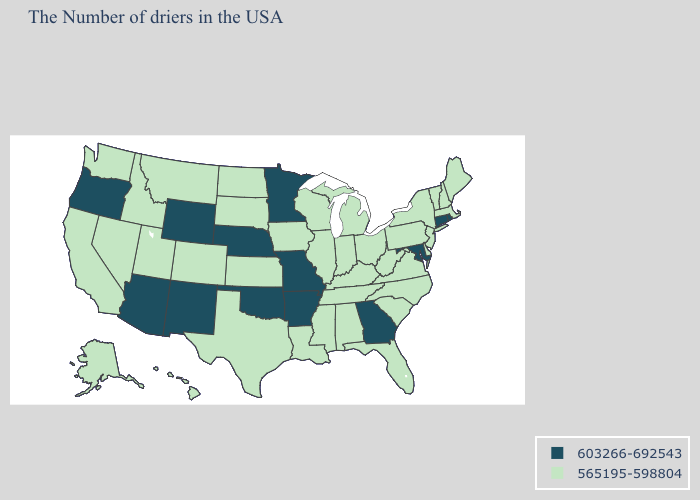What is the value of Indiana?
Answer briefly. 565195-598804. Name the states that have a value in the range 565195-598804?
Give a very brief answer. Maine, Massachusetts, New Hampshire, Vermont, New York, New Jersey, Delaware, Pennsylvania, Virginia, North Carolina, South Carolina, West Virginia, Ohio, Florida, Michigan, Kentucky, Indiana, Alabama, Tennessee, Wisconsin, Illinois, Mississippi, Louisiana, Iowa, Kansas, Texas, South Dakota, North Dakota, Colorado, Utah, Montana, Idaho, Nevada, California, Washington, Alaska, Hawaii. Name the states that have a value in the range 603266-692543?
Keep it brief. Rhode Island, Connecticut, Maryland, Georgia, Missouri, Arkansas, Minnesota, Nebraska, Oklahoma, Wyoming, New Mexico, Arizona, Oregon. What is the value of Texas?
Concise answer only. 565195-598804. Which states have the lowest value in the USA?
Short answer required. Maine, Massachusetts, New Hampshire, Vermont, New York, New Jersey, Delaware, Pennsylvania, Virginia, North Carolina, South Carolina, West Virginia, Ohio, Florida, Michigan, Kentucky, Indiana, Alabama, Tennessee, Wisconsin, Illinois, Mississippi, Louisiana, Iowa, Kansas, Texas, South Dakota, North Dakota, Colorado, Utah, Montana, Idaho, Nevada, California, Washington, Alaska, Hawaii. What is the value of Iowa?
Quick response, please. 565195-598804. Does Rhode Island have the highest value in the Northeast?
Answer briefly. Yes. Does Pennsylvania have the lowest value in the Northeast?
Give a very brief answer. Yes. What is the lowest value in states that border Nebraska?
Write a very short answer. 565195-598804. Name the states that have a value in the range 603266-692543?
Short answer required. Rhode Island, Connecticut, Maryland, Georgia, Missouri, Arkansas, Minnesota, Nebraska, Oklahoma, Wyoming, New Mexico, Arizona, Oregon. Name the states that have a value in the range 565195-598804?
Short answer required. Maine, Massachusetts, New Hampshire, Vermont, New York, New Jersey, Delaware, Pennsylvania, Virginia, North Carolina, South Carolina, West Virginia, Ohio, Florida, Michigan, Kentucky, Indiana, Alabama, Tennessee, Wisconsin, Illinois, Mississippi, Louisiana, Iowa, Kansas, Texas, South Dakota, North Dakota, Colorado, Utah, Montana, Idaho, Nevada, California, Washington, Alaska, Hawaii. What is the value of Delaware?
Short answer required. 565195-598804. What is the highest value in states that border North Dakota?
Keep it brief. 603266-692543. Name the states that have a value in the range 603266-692543?
Give a very brief answer. Rhode Island, Connecticut, Maryland, Georgia, Missouri, Arkansas, Minnesota, Nebraska, Oklahoma, Wyoming, New Mexico, Arizona, Oregon. What is the value of Louisiana?
Give a very brief answer. 565195-598804. 